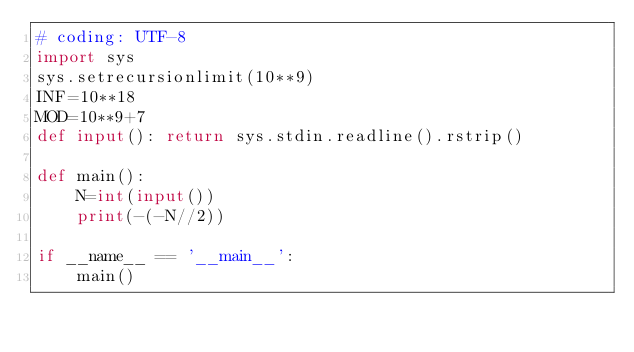<code> <loc_0><loc_0><loc_500><loc_500><_Python_># coding: UTF-8
import sys
sys.setrecursionlimit(10**9)
INF=10**18
MOD=10**9+7
def input(): return sys.stdin.readline().rstrip()

def main():
    N=int(input())
    print(-(-N//2))

if __name__ == '__main__':
    main()
</code> 